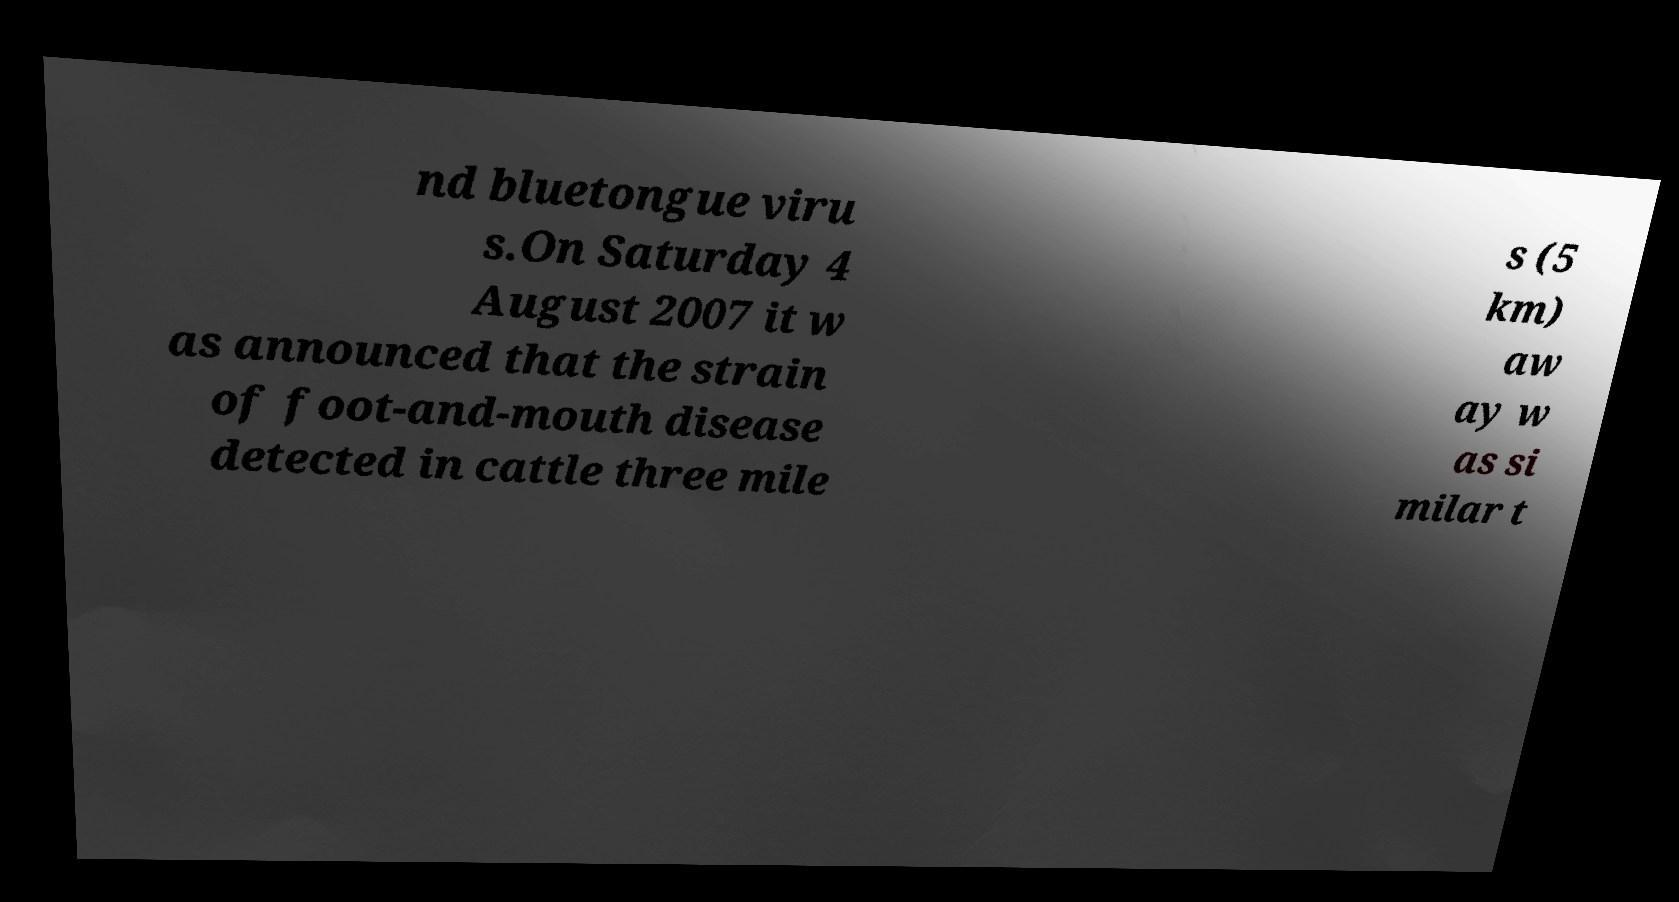Please identify and transcribe the text found in this image. nd bluetongue viru s.On Saturday 4 August 2007 it w as announced that the strain of foot-and-mouth disease detected in cattle three mile s (5 km) aw ay w as si milar t 